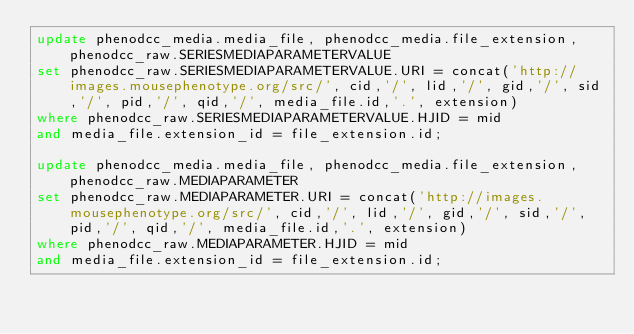<code> <loc_0><loc_0><loc_500><loc_500><_SQL_>update phenodcc_media.media_file, phenodcc_media.file_extension, phenodcc_raw.SERIESMEDIAPARAMETERVALUE
set phenodcc_raw.SERIESMEDIAPARAMETERVALUE.URI = concat('http://images.mousephenotype.org/src/', cid,'/', lid,'/', gid,'/', sid,'/', pid,'/', qid,'/', media_file.id,'.', extension)
where phenodcc_raw.SERIESMEDIAPARAMETERVALUE.HJID = mid
and media_file.extension_id = file_extension.id;

update phenodcc_media.media_file, phenodcc_media.file_extension, phenodcc_raw.MEDIAPARAMETER
set phenodcc_raw.MEDIAPARAMETER.URI = concat('http://images.mousephenotype.org/src/', cid,'/', lid,'/', gid,'/', sid,'/', pid,'/', qid,'/', media_file.id,'.', extension)
where phenodcc_raw.MEDIAPARAMETER.HJID = mid
and media_file.extension_id = file_extension.id;
</code> 